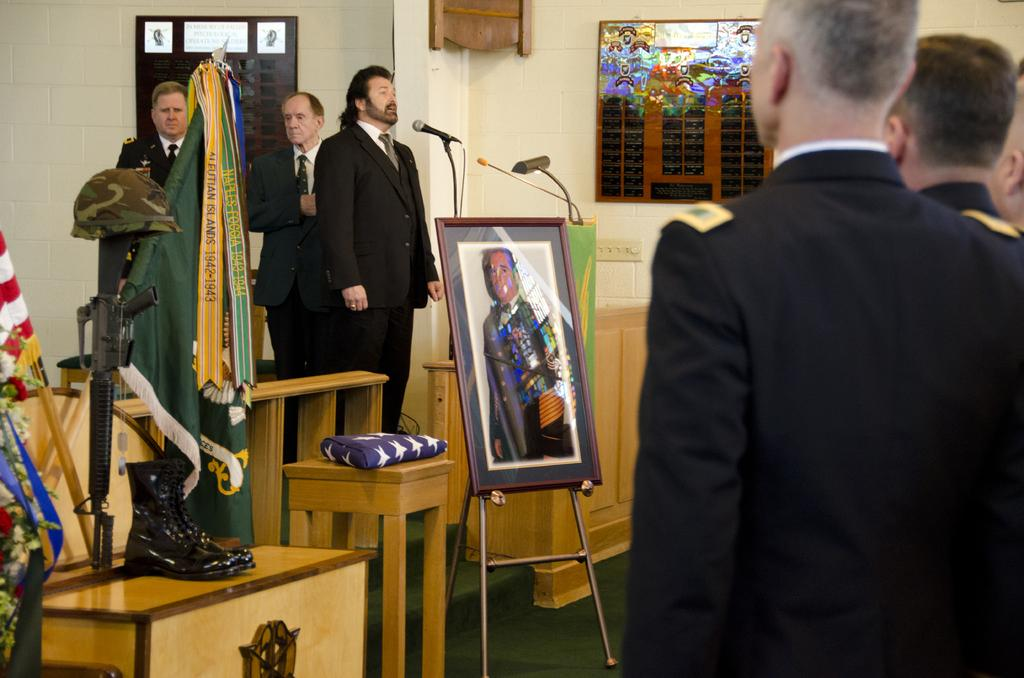What is happening in the image? There are persons standing in the image. What object can be seen hanging on the wall? There is a photo frame in the image. Where is the gun located in the image? The gun is on the left side of the image. What is placed on the table in the image? There is a shoe on a table in the image. What type of ring can be seen on the person's finger in the image? There is no ring visible on any person's finger in the image. What type of polish is being applied to the shoe on the table in the image? There is no indication of polish or any activity related to polishing in the image. 